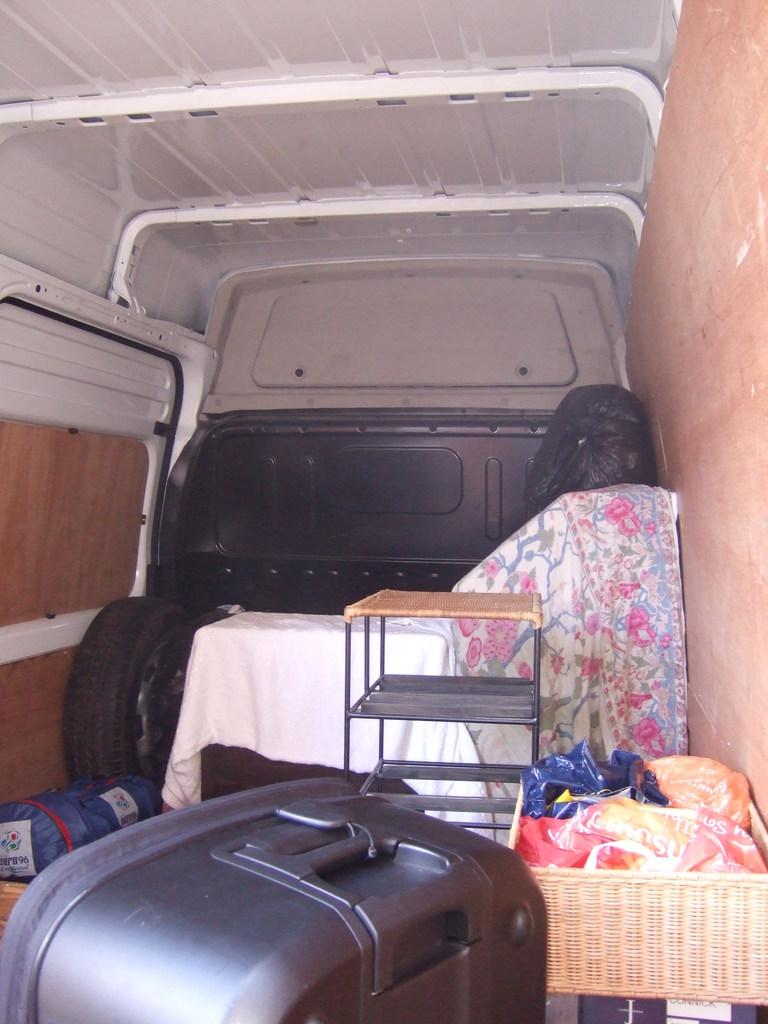What type of space is shown in the image? The image shows an inside view of a vehicle. What can be seen inside the vehicle? There is a luggage bag, a table, clothes, baskets, and another table visible in the image. What is inside the baskets? Covers are inside the baskets. Is there any part of the vehicle visible in the image? Yes, a tire is visible in the image. What type of cabbage is being transported by the lawyer in the image? There is no cabbage or lawyer present in the image. The image shows an inside view of a vehicle with various items and objects, but no people or food items are visible. 